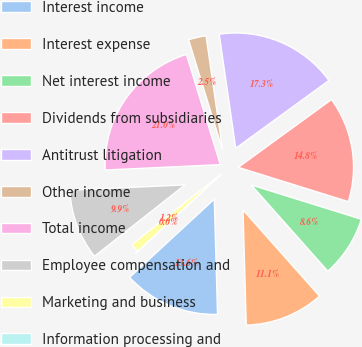Convert chart. <chart><loc_0><loc_0><loc_500><loc_500><pie_chart><fcel>Interest income<fcel>Interest expense<fcel>Net interest income<fcel>Dividends from subsidiaries<fcel>Antitrust litigation<fcel>Other income<fcel>Total income<fcel>Employee compensation and<fcel>Marketing and business<fcel>Information processing and<nl><fcel>13.58%<fcel>11.11%<fcel>8.64%<fcel>14.81%<fcel>17.28%<fcel>2.47%<fcel>20.99%<fcel>9.88%<fcel>1.24%<fcel>0.0%<nl></chart> 